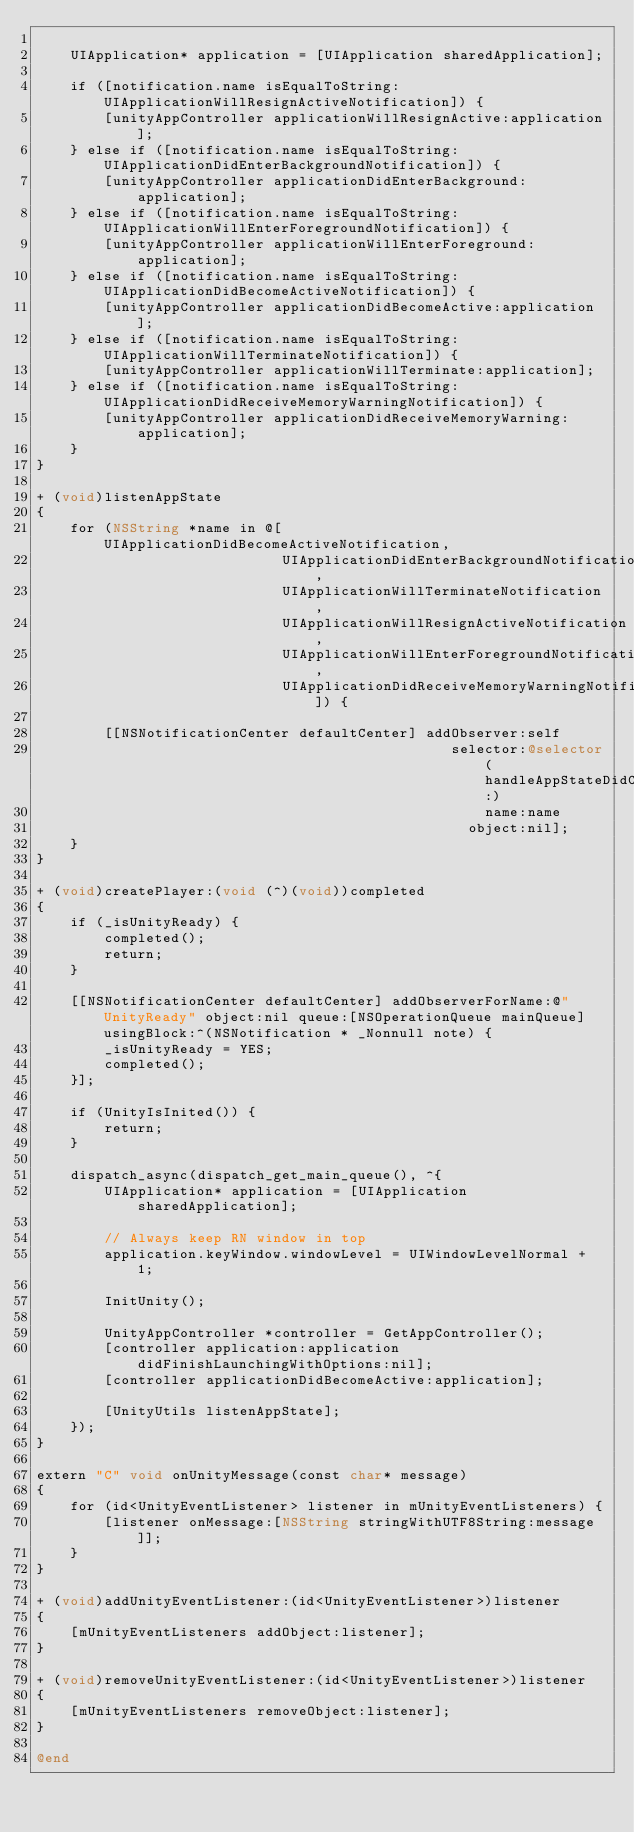<code> <loc_0><loc_0><loc_500><loc_500><_ObjectiveC_>
    UIApplication* application = [UIApplication sharedApplication];

    if ([notification.name isEqualToString:UIApplicationWillResignActiveNotification]) {
        [unityAppController applicationWillResignActive:application];
    } else if ([notification.name isEqualToString:UIApplicationDidEnterBackgroundNotification]) {
        [unityAppController applicationDidEnterBackground:application];
    } else if ([notification.name isEqualToString:UIApplicationWillEnterForegroundNotification]) {
        [unityAppController applicationWillEnterForeground:application];
    } else if ([notification.name isEqualToString:UIApplicationDidBecomeActiveNotification]) {
        [unityAppController applicationDidBecomeActive:application];
    } else if ([notification.name isEqualToString:UIApplicationWillTerminateNotification]) {
        [unityAppController applicationWillTerminate:application];
    } else if ([notification.name isEqualToString:UIApplicationDidReceiveMemoryWarningNotification]) {
        [unityAppController applicationDidReceiveMemoryWarning:application];
    }
}

+ (void)listenAppState
{
    for (NSString *name in @[UIApplicationDidBecomeActiveNotification,
                             UIApplicationDidEnterBackgroundNotification,
                             UIApplicationWillTerminateNotification,
                             UIApplicationWillResignActiveNotification,
                             UIApplicationWillEnterForegroundNotification,
                             UIApplicationDidReceiveMemoryWarningNotification]) {

        [[NSNotificationCenter defaultCenter] addObserver:self
                                                 selector:@selector(handleAppStateDidChange:)
                                                     name:name
                                                   object:nil];
    }
}

+ (void)createPlayer:(void (^)(void))completed
{
    if (_isUnityReady) {
        completed();
        return;
    }

    [[NSNotificationCenter defaultCenter] addObserverForName:@"UnityReady" object:nil queue:[NSOperationQueue mainQueue]  usingBlock:^(NSNotification * _Nonnull note) {
        _isUnityReady = YES;
        completed();
    }];

    if (UnityIsInited()) {
        return;
    }

    dispatch_async(dispatch_get_main_queue(), ^{
        UIApplication* application = [UIApplication sharedApplication];

        // Always keep RN window in top
        application.keyWindow.windowLevel = UIWindowLevelNormal + 1;

        InitUnity();

        UnityAppController *controller = GetAppController();
        [controller application:application didFinishLaunchingWithOptions:nil];
        [controller applicationDidBecomeActive:application];

        [UnityUtils listenAppState];
    });
}

extern "C" void onUnityMessage(const char* message)
{
    for (id<UnityEventListener> listener in mUnityEventListeners) {
        [listener onMessage:[NSString stringWithUTF8String:message]];
    }
}

+ (void)addUnityEventListener:(id<UnityEventListener>)listener
{
    [mUnityEventListeners addObject:listener];
}

+ (void)removeUnityEventListener:(id<UnityEventListener>)listener
{
    [mUnityEventListeners removeObject:listener];
}

@end
</code> 